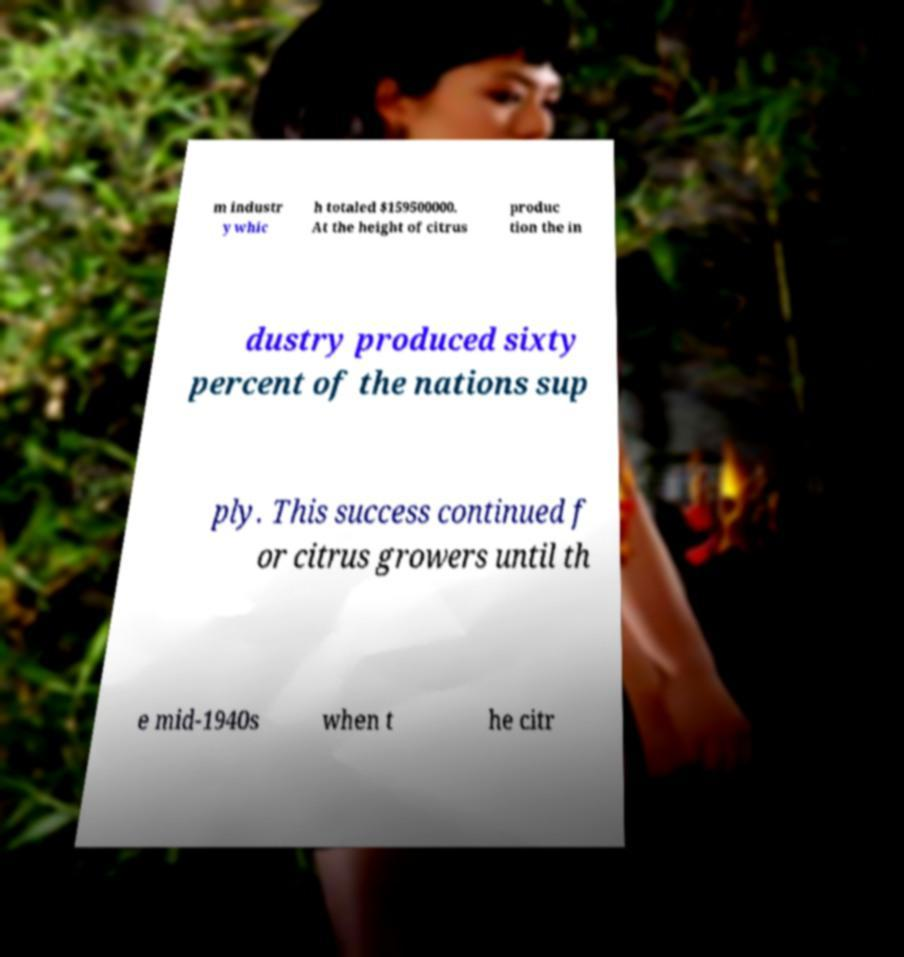Could you assist in decoding the text presented in this image and type it out clearly? m industr y whic h totaled $159500000. At the height of citrus produc tion the in dustry produced sixty percent of the nations sup ply. This success continued f or citrus growers until th e mid-1940s when t he citr 